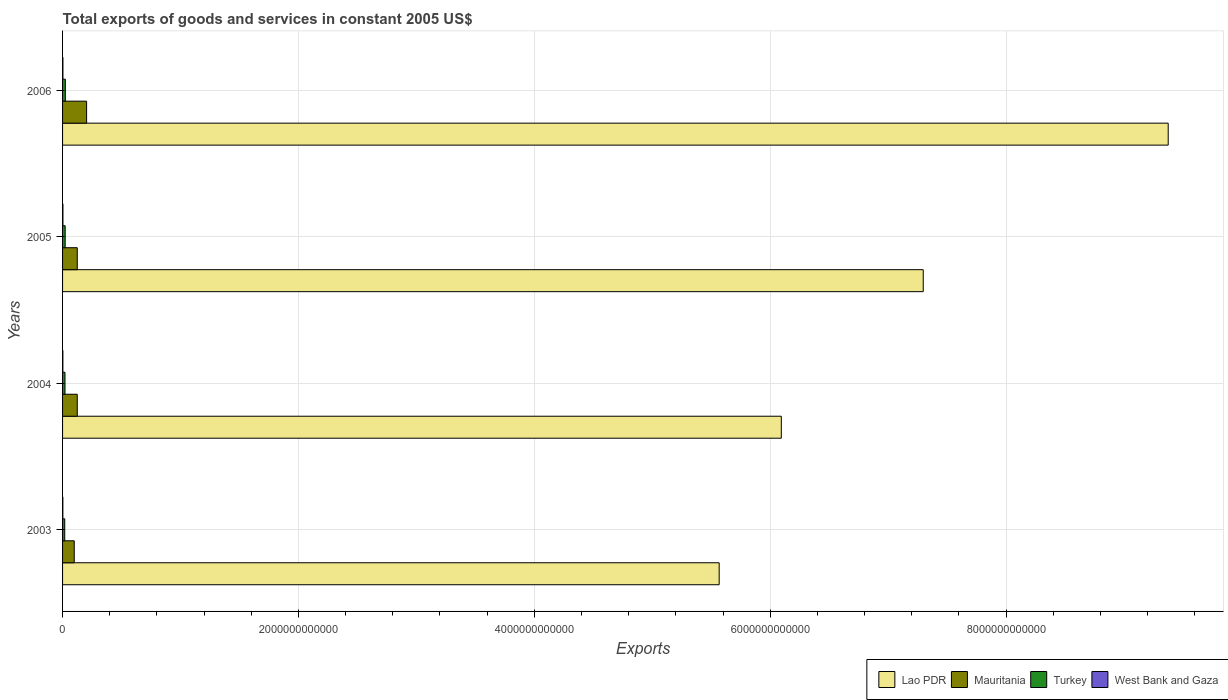How many different coloured bars are there?
Provide a succinct answer. 4. How many groups of bars are there?
Keep it short and to the point. 4. Are the number of bars per tick equal to the number of legend labels?
Give a very brief answer. Yes. Are the number of bars on each tick of the Y-axis equal?
Your response must be concise. Yes. What is the total exports of goods and services in Mauritania in 2005?
Offer a terse response. 1.25e+11. Across all years, what is the maximum total exports of goods and services in Turkey?
Provide a short and direct response. 2.36e+1. Across all years, what is the minimum total exports of goods and services in Lao PDR?
Ensure brevity in your answer.  5.57e+12. What is the total total exports of goods and services in Mauritania in the graph?
Keep it short and to the point. 5.52e+11. What is the difference between the total exports of goods and services in West Bank and Gaza in 2004 and that in 2006?
Provide a succinct answer. -3.74e+08. What is the difference between the total exports of goods and services in Lao PDR in 2004 and the total exports of goods and services in Mauritania in 2003?
Your answer should be compact. 6.00e+12. What is the average total exports of goods and services in Lao PDR per year?
Your answer should be compact. 7.08e+12. In the year 2003, what is the difference between the total exports of goods and services in West Bank and Gaza and total exports of goods and services in Lao PDR?
Your response must be concise. -5.57e+12. In how many years, is the total exports of goods and services in Turkey greater than 4000000000000 US$?
Provide a short and direct response. 0. What is the ratio of the total exports of goods and services in Lao PDR in 2003 to that in 2006?
Provide a short and direct response. 0.59. Is the total exports of goods and services in West Bank and Gaza in 2004 less than that in 2005?
Give a very brief answer. Yes. Is the difference between the total exports of goods and services in West Bank and Gaza in 2004 and 2005 greater than the difference between the total exports of goods and services in Lao PDR in 2004 and 2005?
Offer a very short reply. Yes. What is the difference between the highest and the second highest total exports of goods and services in Mauritania?
Your answer should be very brief. 7.92e+1. What is the difference between the highest and the lowest total exports of goods and services in West Bank and Gaza?
Offer a terse response. 7.08e+08. In how many years, is the total exports of goods and services in Lao PDR greater than the average total exports of goods and services in Lao PDR taken over all years?
Your answer should be very brief. 2. What does the 3rd bar from the top in 2006 represents?
Provide a short and direct response. Mauritania. What does the 2nd bar from the bottom in 2006 represents?
Offer a very short reply. Mauritania. How many bars are there?
Provide a short and direct response. 16. Are all the bars in the graph horizontal?
Provide a succinct answer. Yes. What is the difference between two consecutive major ticks on the X-axis?
Your answer should be compact. 2.00e+12. Are the values on the major ticks of X-axis written in scientific E-notation?
Give a very brief answer. No. Does the graph contain any zero values?
Provide a succinct answer. No. Does the graph contain grids?
Your response must be concise. Yes. How are the legend labels stacked?
Ensure brevity in your answer.  Horizontal. What is the title of the graph?
Provide a short and direct response. Total exports of goods and services in constant 2005 US$. Does "South Africa" appear as one of the legend labels in the graph?
Give a very brief answer. No. What is the label or title of the X-axis?
Your answer should be very brief. Exports. What is the label or title of the Y-axis?
Keep it short and to the point. Years. What is the Exports of Lao PDR in 2003?
Give a very brief answer. 5.57e+12. What is the Exports in Mauritania in 2003?
Ensure brevity in your answer.  9.89e+1. What is the Exports of Turkey in 2003?
Your response must be concise. 1.84e+1. What is the Exports of West Bank and Gaza in 2003?
Offer a very short reply. 2.45e+09. What is the Exports in Lao PDR in 2004?
Your response must be concise. 6.09e+12. What is the Exports of Mauritania in 2004?
Your response must be concise. 1.25e+11. What is the Exports in Turkey in 2004?
Keep it short and to the point. 2.05e+1. What is the Exports of West Bank and Gaza in 2004?
Provide a short and direct response. 2.67e+09. What is the Exports of Lao PDR in 2005?
Make the answer very short. 7.30e+12. What is the Exports in Mauritania in 2005?
Offer a terse response. 1.25e+11. What is the Exports in Turkey in 2005?
Make the answer very short. 2.21e+1. What is the Exports of West Bank and Gaza in 2005?
Your answer should be very brief. 3.16e+09. What is the Exports in Lao PDR in 2006?
Provide a succinct answer. 9.37e+12. What is the Exports in Mauritania in 2006?
Ensure brevity in your answer.  2.04e+11. What is the Exports in Turkey in 2006?
Your answer should be very brief. 2.36e+1. What is the Exports of West Bank and Gaza in 2006?
Your answer should be compact. 3.05e+09. Across all years, what is the maximum Exports of Lao PDR?
Your response must be concise. 9.37e+12. Across all years, what is the maximum Exports of Mauritania?
Your answer should be very brief. 2.04e+11. Across all years, what is the maximum Exports of Turkey?
Keep it short and to the point. 2.36e+1. Across all years, what is the maximum Exports of West Bank and Gaza?
Your answer should be compact. 3.16e+09. Across all years, what is the minimum Exports in Lao PDR?
Ensure brevity in your answer.  5.57e+12. Across all years, what is the minimum Exports in Mauritania?
Your answer should be very brief. 9.89e+1. Across all years, what is the minimum Exports in Turkey?
Offer a very short reply. 1.84e+1. Across all years, what is the minimum Exports in West Bank and Gaza?
Provide a short and direct response. 2.45e+09. What is the total Exports in Lao PDR in the graph?
Make the answer very short. 2.83e+13. What is the total Exports of Mauritania in the graph?
Ensure brevity in your answer.  5.52e+11. What is the total Exports in Turkey in the graph?
Provide a short and direct response. 8.46e+1. What is the total Exports in West Bank and Gaza in the graph?
Give a very brief answer. 1.13e+1. What is the difference between the Exports of Lao PDR in 2003 and that in 2004?
Make the answer very short. -5.27e+11. What is the difference between the Exports of Mauritania in 2003 and that in 2004?
Offer a very short reply. -2.57e+1. What is the difference between the Exports in Turkey in 2003 and that in 2004?
Make the answer very short. -2.06e+09. What is the difference between the Exports in West Bank and Gaza in 2003 and that in 2004?
Make the answer very short. -2.19e+08. What is the difference between the Exports of Lao PDR in 2003 and that in 2005?
Make the answer very short. -1.73e+12. What is the difference between the Exports in Mauritania in 2003 and that in 2005?
Keep it short and to the point. -2.57e+1. What is the difference between the Exports of Turkey in 2003 and that in 2005?
Provide a short and direct response. -3.67e+09. What is the difference between the Exports in West Bank and Gaza in 2003 and that in 2005?
Keep it short and to the point. -7.08e+08. What is the difference between the Exports of Lao PDR in 2003 and that in 2006?
Give a very brief answer. -3.81e+12. What is the difference between the Exports in Mauritania in 2003 and that in 2006?
Provide a succinct answer. -1.05e+11. What is the difference between the Exports of Turkey in 2003 and that in 2006?
Make the answer very short. -5.14e+09. What is the difference between the Exports in West Bank and Gaza in 2003 and that in 2006?
Offer a very short reply. -5.94e+08. What is the difference between the Exports of Lao PDR in 2004 and that in 2005?
Offer a terse response. -1.20e+12. What is the difference between the Exports of Mauritania in 2004 and that in 2005?
Your answer should be very brief. -5.00e+06. What is the difference between the Exports in Turkey in 2004 and that in 2005?
Ensure brevity in your answer.  -1.62e+09. What is the difference between the Exports of West Bank and Gaza in 2004 and that in 2005?
Ensure brevity in your answer.  -4.89e+08. What is the difference between the Exports in Lao PDR in 2004 and that in 2006?
Give a very brief answer. -3.28e+12. What is the difference between the Exports of Mauritania in 2004 and that in 2006?
Provide a succinct answer. -7.92e+1. What is the difference between the Exports of Turkey in 2004 and that in 2006?
Make the answer very short. -3.08e+09. What is the difference between the Exports of West Bank and Gaza in 2004 and that in 2006?
Your response must be concise. -3.74e+08. What is the difference between the Exports in Lao PDR in 2005 and that in 2006?
Keep it short and to the point. -2.08e+12. What is the difference between the Exports in Mauritania in 2005 and that in 2006?
Provide a short and direct response. -7.92e+1. What is the difference between the Exports in Turkey in 2005 and that in 2006?
Make the answer very short. -1.47e+09. What is the difference between the Exports of West Bank and Gaza in 2005 and that in 2006?
Provide a succinct answer. 1.15e+08. What is the difference between the Exports of Lao PDR in 2003 and the Exports of Mauritania in 2004?
Provide a short and direct response. 5.44e+12. What is the difference between the Exports of Lao PDR in 2003 and the Exports of Turkey in 2004?
Offer a very short reply. 5.55e+12. What is the difference between the Exports in Lao PDR in 2003 and the Exports in West Bank and Gaza in 2004?
Your answer should be very brief. 5.56e+12. What is the difference between the Exports of Mauritania in 2003 and the Exports of Turkey in 2004?
Keep it short and to the point. 7.85e+1. What is the difference between the Exports in Mauritania in 2003 and the Exports in West Bank and Gaza in 2004?
Your answer should be compact. 9.63e+1. What is the difference between the Exports of Turkey in 2003 and the Exports of West Bank and Gaza in 2004?
Give a very brief answer. 1.57e+1. What is the difference between the Exports of Lao PDR in 2003 and the Exports of Mauritania in 2005?
Ensure brevity in your answer.  5.44e+12. What is the difference between the Exports in Lao PDR in 2003 and the Exports in Turkey in 2005?
Ensure brevity in your answer.  5.55e+12. What is the difference between the Exports of Lao PDR in 2003 and the Exports of West Bank and Gaza in 2005?
Offer a terse response. 5.56e+12. What is the difference between the Exports of Mauritania in 2003 and the Exports of Turkey in 2005?
Keep it short and to the point. 7.68e+1. What is the difference between the Exports in Mauritania in 2003 and the Exports in West Bank and Gaza in 2005?
Your answer should be very brief. 9.58e+1. What is the difference between the Exports of Turkey in 2003 and the Exports of West Bank and Gaza in 2005?
Your answer should be compact. 1.53e+1. What is the difference between the Exports of Lao PDR in 2003 and the Exports of Mauritania in 2006?
Offer a very short reply. 5.36e+12. What is the difference between the Exports in Lao PDR in 2003 and the Exports in Turkey in 2006?
Your answer should be compact. 5.54e+12. What is the difference between the Exports in Lao PDR in 2003 and the Exports in West Bank and Gaza in 2006?
Provide a succinct answer. 5.56e+12. What is the difference between the Exports in Mauritania in 2003 and the Exports in Turkey in 2006?
Keep it short and to the point. 7.54e+1. What is the difference between the Exports of Mauritania in 2003 and the Exports of West Bank and Gaza in 2006?
Your answer should be compact. 9.59e+1. What is the difference between the Exports of Turkey in 2003 and the Exports of West Bank and Gaza in 2006?
Provide a short and direct response. 1.54e+1. What is the difference between the Exports in Lao PDR in 2004 and the Exports in Mauritania in 2005?
Provide a short and direct response. 5.97e+12. What is the difference between the Exports of Lao PDR in 2004 and the Exports of Turkey in 2005?
Provide a succinct answer. 6.07e+12. What is the difference between the Exports in Lao PDR in 2004 and the Exports in West Bank and Gaza in 2005?
Your answer should be compact. 6.09e+12. What is the difference between the Exports in Mauritania in 2004 and the Exports in Turkey in 2005?
Offer a very short reply. 1.03e+11. What is the difference between the Exports in Mauritania in 2004 and the Exports in West Bank and Gaza in 2005?
Keep it short and to the point. 1.21e+11. What is the difference between the Exports in Turkey in 2004 and the Exports in West Bank and Gaza in 2005?
Ensure brevity in your answer.  1.73e+1. What is the difference between the Exports in Lao PDR in 2004 and the Exports in Mauritania in 2006?
Offer a terse response. 5.89e+12. What is the difference between the Exports in Lao PDR in 2004 and the Exports in Turkey in 2006?
Provide a succinct answer. 6.07e+12. What is the difference between the Exports of Lao PDR in 2004 and the Exports of West Bank and Gaza in 2006?
Your response must be concise. 6.09e+12. What is the difference between the Exports of Mauritania in 2004 and the Exports of Turkey in 2006?
Your response must be concise. 1.01e+11. What is the difference between the Exports in Mauritania in 2004 and the Exports in West Bank and Gaza in 2006?
Give a very brief answer. 1.22e+11. What is the difference between the Exports of Turkey in 2004 and the Exports of West Bank and Gaza in 2006?
Your answer should be compact. 1.74e+1. What is the difference between the Exports of Lao PDR in 2005 and the Exports of Mauritania in 2006?
Your response must be concise. 7.09e+12. What is the difference between the Exports of Lao PDR in 2005 and the Exports of Turkey in 2006?
Your response must be concise. 7.27e+12. What is the difference between the Exports in Lao PDR in 2005 and the Exports in West Bank and Gaza in 2006?
Make the answer very short. 7.29e+12. What is the difference between the Exports of Mauritania in 2005 and the Exports of Turkey in 2006?
Keep it short and to the point. 1.01e+11. What is the difference between the Exports in Mauritania in 2005 and the Exports in West Bank and Gaza in 2006?
Offer a very short reply. 1.22e+11. What is the difference between the Exports of Turkey in 2005 and the Exports of West Bank and Gaza in 2006?
Provide a succinct answer. 1.90e+1. What is the average Exports in Lao PDR per year?
Keep it short and to the point. 7.08e+12. What is the average Exports of Mauritania per year?
Give a very brief answer. 1.38e+11. What is the average Exports of Turkey per year?
Your answer should be very brief. 2.11e+1. What is the average Exports in West Bank and Gaza per year?
Provide a succinct answer. 2.83e+09. In the year 2003, what is the difference between the Exports of Lao PDR and Exports of Mauritania?
Provide a succinct answer. 5.47e+12. In the year 2003, what is the difference between the Exports of Lao PDR and Exports of Turkey?
Your response must be concise. 5.55e+12. In the year 2003, what is the difference between the Exports of Lao PDR and Exports of West Bank and Gaza?
Give a very brief answer. 5.57e+12. In the year 2003, what is the difference between the Exports in Mauritania and Exports in Turkey?
Your response must be concise. 8.05e+1. In the year 2003, what is the difference between the Exports in Mauritania and Exports in West Bank and Gaza?
Offer a very short reply. 9.65e+1. In the year 2003, what is the difference between the Exports in Turkey and Exports in West Bank and Gaza?
Offer a very short reply. 1.60e+1. In the year 2004, what is the difference between the Exports of Lao PDR and Exports of Mauritania?
Keep it short and to the point. 5.97e+12. In the year 2004, what is the difference between the Exports of Lao PDR and Exports of Turkey?
Provide a succinct answer. 6.07e+12. In the year 2004, what is the difference between the Exports in Lao PDR and Exports in West Bank and Gaza?
Your answer should be very brief. 6.09e+12. In the year 2004, what is the difference between the Exports in Mauritania and Exports in Turkey?
Offer a very short reply. 1.04e+11. In the year 2004, what is the difference between the Exports in Mauritania and Exports in West Bank and Gaza?
Your response must be concise. 1.22e+11. In the year 2004, what is the difference between the Exports of Turkey and Exports of West Bank and Gaza?
Your answer should be compact. 1.78e+1. In the year 2005, what is the difference between the Exports of Lao PDR and Exports of Mauritania?
Give a very brief answer. 7.17e+12. In the year 2005, what is the difference between the Exports of Lao PDR and Exports of Turkey?
Your response must be concise. 7.28e+12. In the year 2005, what is the difference between the Exports in Lao PDR and Exports in West Bank and Gaza?
Give a very brief answer. 7.29e+12. In the year 2005, what is the difference between the Exports of Mauritania and Exports of Turkey?
Ensure brevity in your answer.  1.03e+11. In the year 2005, what is the difference between the Exports of Mauritania and Exports of West Bank and Gaza?
Provide a short and direct response. 1.21e+11. In the year 2005, what is the difference between the Exports in Turkey and Exports in West Bank and Gaza?
Give a very brief answer. 1.89e+1. In the year 2006, what is the difference between the Exports in Lao PDR and Exports in Mauritania?
Offer a terse response. 9.17e+12. In the year 2006, what is the difference between the Exports of Lao PDR and Exports of Turkey?
Your answer should be compact. 9.35e+12. In the year 2006, what is the difference between the Exports of Lao PDR and Exports of West Bank and Gaza?
Give a very brief answer. 9.37e+12. In the year 2006, what is the difference between the Exports of Mauritania and Exports of Turkey?
Provide a short and direct response. 1.80e+11. In the year 2006, what is the difference between the Exports in Mauritania and Exports in West Bank and Gaza?
Offer a terse response. 2.01e+11. In the year 2006, what is the difference between the Exports of Turkey and Exports of West Bank and Gaza?
Your response must be concise. 2.05e+1. What is the ratio of the Exports of Lao PDR in 2003 to that in 2004?
Your response must be concise. 0.91. What is the ratio of the Exports of Mauritania in 2003 to that in 2004?
Offer a terse response. 0.79. What is the ratio of the Exports in Turkey in 2003 to that in 2004?
Provide a short and direct response. 0.9. What is the ratio of the Exports in West Bank and Gaza in 2003 to that in 2004?
Your answer should be compact. 0.92. What is the ratio of the Exports of Lao PDR in 2003 to that in 2005?
Provide a succinct answer. 0.76. What is the ratio of the Exports of Mauritania in 2003 to that in 2005?
Your response must be concise. 0.79. What is the ratio of the Exports in Turkey in 2003 to that in 2005?
Keep it short and to the point. 0.83. What is the ratio of the Exports of West Bank and Gaza in 2003 to that in 2005?
Your response must be concise. 0.78. What is the ratio of the Exports of Lao PDR in 2003 to that in 2006?
Ensure brevity in your answer.  0.59. What is the ratio of the Exports of Mauritania in 2003 to that in 2006?
Ensure brevity in your answer.  0.49. What is the ratio of the Exports in Turkey in 2003 to that in 2006?
Give a very brief answer. 0.78. What is the ratio of the Exports of West Bank and Gaza in 2003 to that in 2006?
Provide a succinct answer. 0.81. What is the ratio of the Exports of Lao PDR in 2004 to that in 2005?
Your answer should be compact. 0.84. What is the ratio of the Exports of Mauritania in 2004 to that in 2005?
Your answer should be compact. 1. What is the ratio of the Exports in Turkey in 2004 to that in 2005?
Provide a short and direct response. 0.93. What is the ratio of the Exports in West Bank and Gaza in 2004 to that in 2005?
Your response must be concise. 0.85. What is the ratio of the Exports of Lao PDR in 2004 to that in 2006?
Offer a terse response. 0.65. What is the ratio of the Exports of Mauritania in 2004 to that in 2006?
Make the answer very short. 0.61. What is the ratio of the Exports in Turkey in 2004 to that in 2006?
Make the answer very short. 0.87. What is the ratio of the Exports in West Bank and Gaza in 2004 to that in 2006?
Provide a succinct answer. 0.88. What is the ratio of the Exports in Lao PDR in 2005 to that in 2006?
Provide a succinct answer. 0.78. What is the ratio of the Exports in Mauritania in 2005 to that in 2006?
Ensure brevity in your answer.  0.61. What is the ratio of the Exports in Turkey in 2005 to that in 2006?
Keep it short and to the point. 0.94. What is the ratio of the Exports of West Bank and Gaza in 2005 to that in 2006?
Offer a terse response. 1.04. What is the difference between the highest and the second highest Exports of Lao PDR?
Give a very brief answer. 2.08e+12. What is the difference between the highest and the second highest Exports in Mauritania?
Ensure brevity in your answer.  7.92e+1. What is the difference between the highest and the second highest Exports of Turkey?
Keep it short and to the point. 1.47e+09. What is the difference between the highest and the second highest Exports of West Bank and Gaza?
Make the answer very short. 1.15e+08. What is the difference between the highest and the lowest Exports of Lao PDR?
Keep it short and to the point. 3.81e+12. What is the difference between the highest and the lowest Exports in Mauritania?
Ensure brevity in your answer.  1.05e+11. What is the difference between the highest and the lowest Exports of Turkey?
Your answer should be very brief. 5.14e+09. What is the difference between the highest and the lowest Exports in West Bank and Gaza?
Provide a succinct answer. 7.08e+08. 